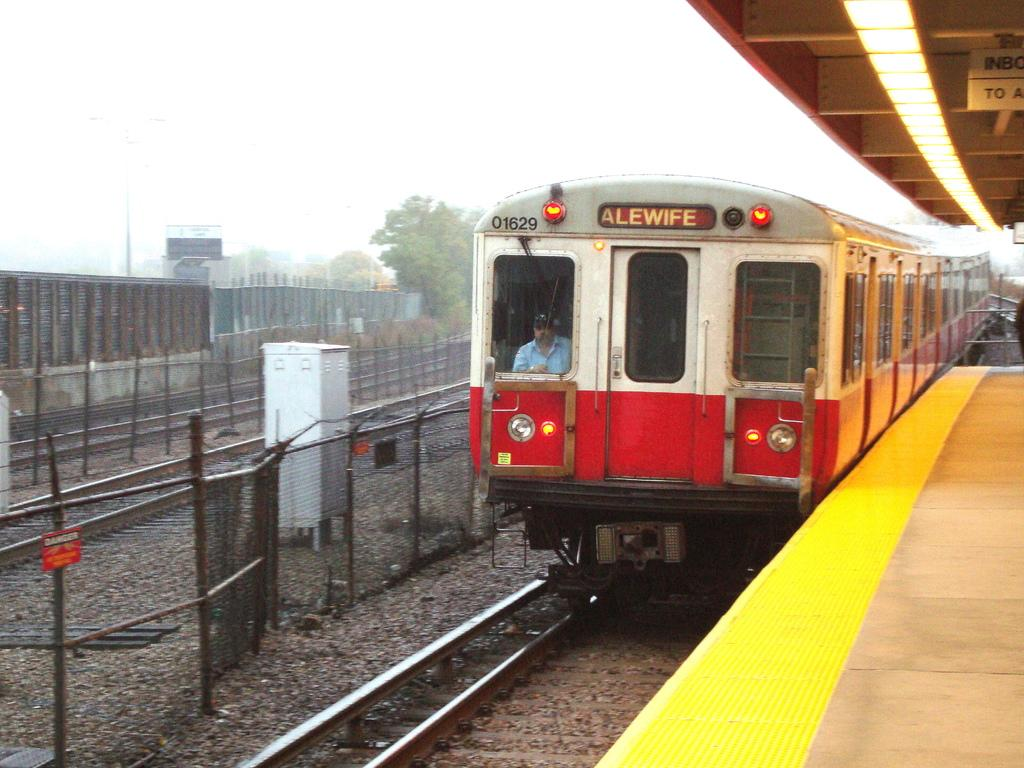<image>
Present a compact description of the photo's key features. A train that says Alewife on it is parked at the station. 